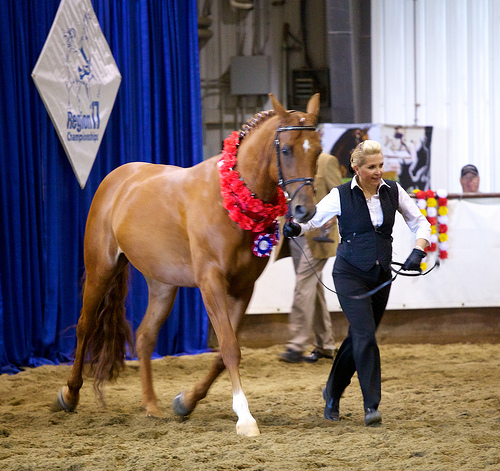<image>
Can you confirm if the woman is on the horse? No. The woman is not positioned on the horse. They may be near each other, but the woman is not supported by or resting on top of the horse. Where is the women in relation to the horse? Is it to the left of the horse? Yes. From this viewpoint, the women is positioned to the left side relative to the horse. Is there a horse in the show? Yes. The horse is contained within or inside the show, showing a containment relationship. Is the horse in front of the jockey? No. The horse is not in front of the jockey. The spatial positioning shows a different relationship between these objects. 